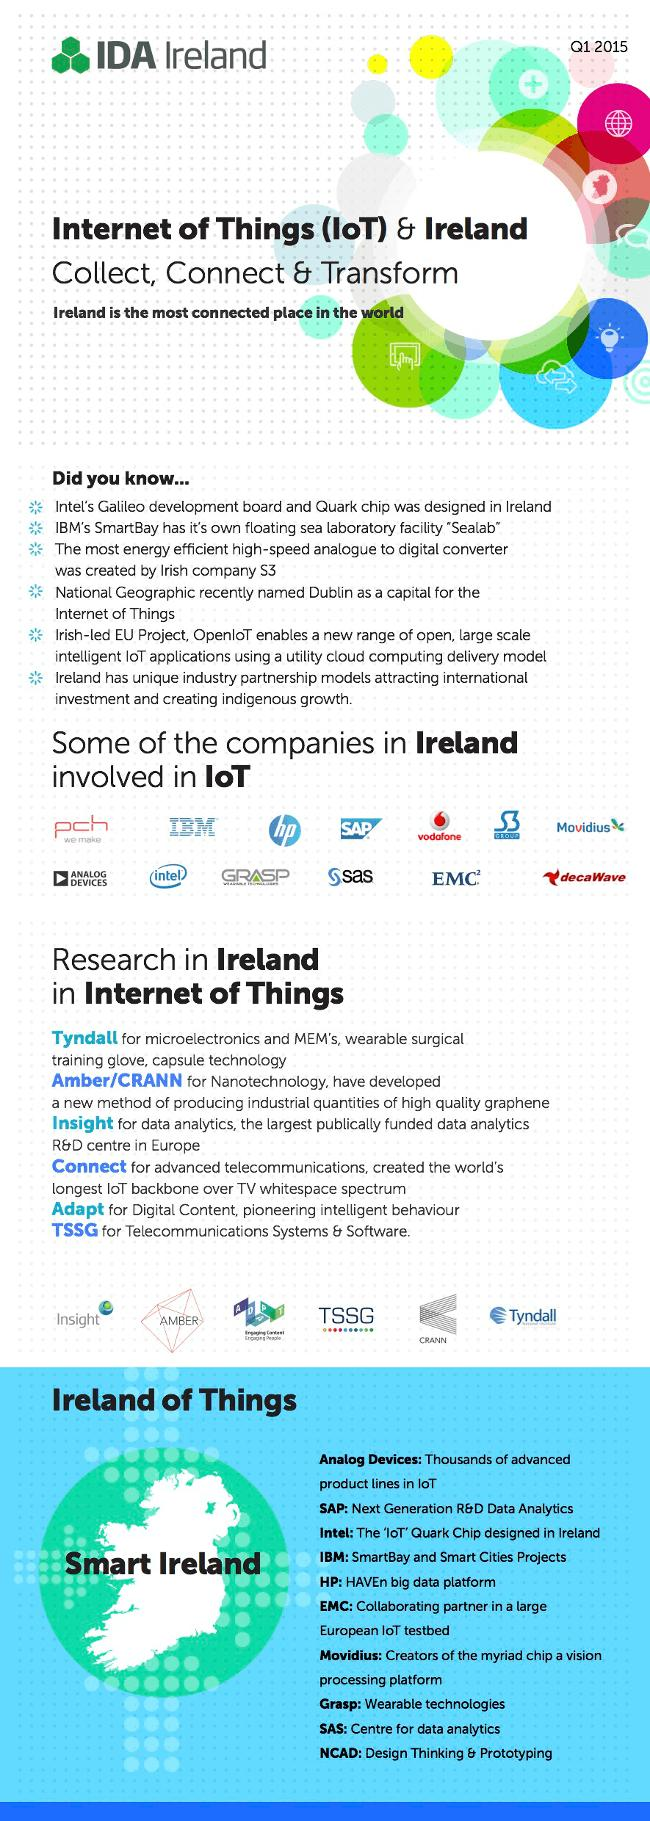Outline some significant characteristics in this image. According to our research, 13 companies in Ireland are currently involved in the Internet of Things (IoT) industry. 